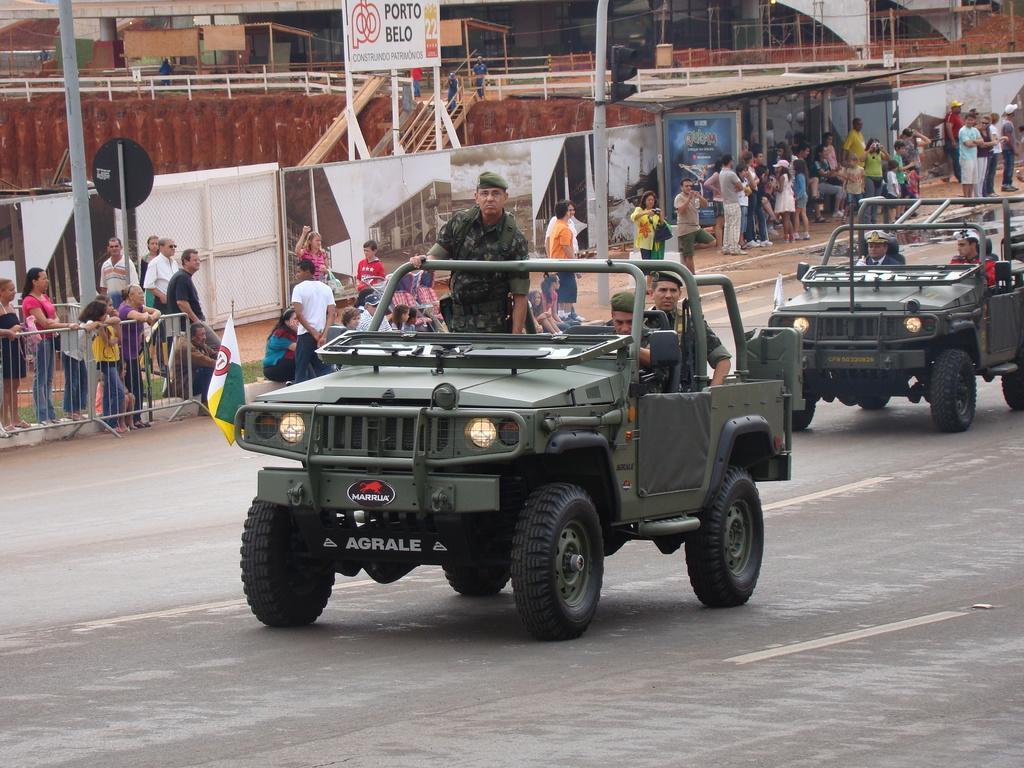Can you describe this image briefly? In the picture I can see two vehicles on the road and there are a few persons in the vehicles. I can see a group of people standing on the side. I can see the metal fencing and poles on the side of the road. I can see the glass windows of a building at the top of the picture. 